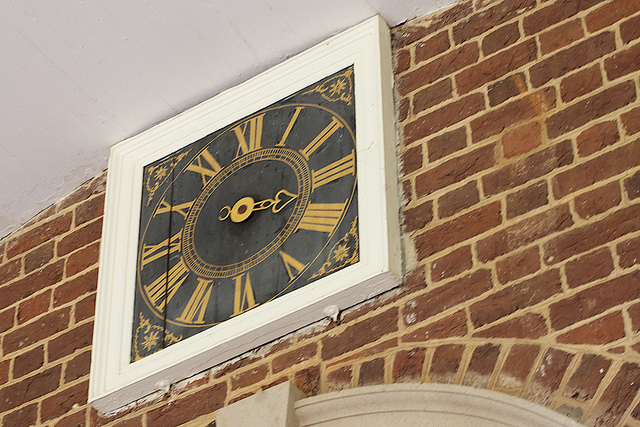Identify the text contained in this image. VI V III XI III VII VIII IX X II I XII 